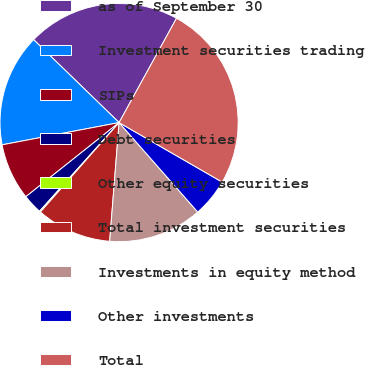Convert chart to OTSL. <chart><loc_0><loc_0><loc_500><loc_500><pie_chart><fcel>as of September 30<fcel>Investment securities trading<fcel>SIPs<fcel>Debt securities<fcel>Other equity securities<fcel>Total investment securities<fcel>Investments in equity method<fcel>Other investments<fcel>Total<nl><fcel>20.75%<fcel>15.25%<fcel>7.7%<fcel>2.67%<fcel>0.16%<fcel>10.22%<fcel>12.74%<fcel>5.19%<fcel>25.32%<nl></chart> 